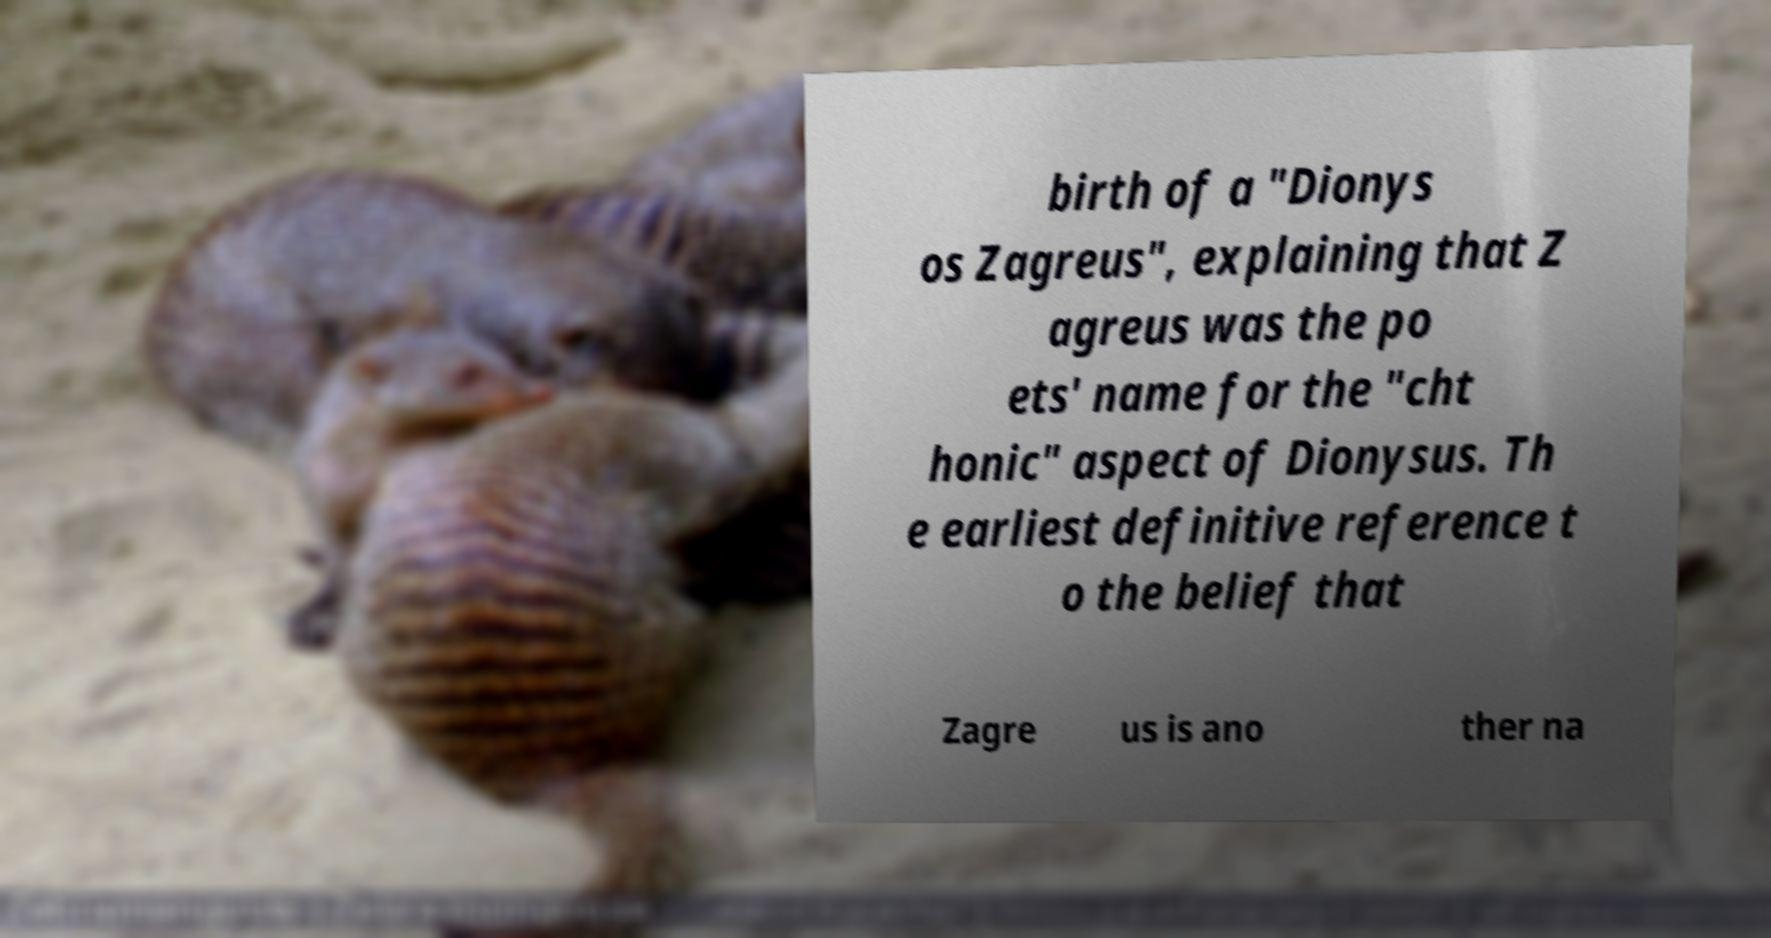Please read and relay the text visible in this image. What does it say? birth of a "Dionys os Zagreus", explaining that Z agreus was the po ets' name for the "cht honic" aspect of Dionysus. Th e earliest definitive reference t o the belief that Zagre us is ano ther na 